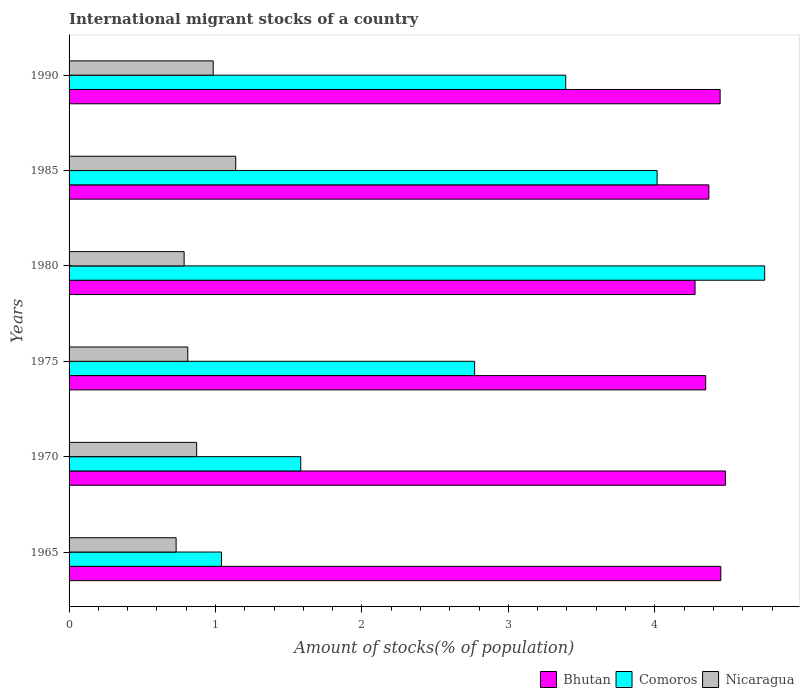How many groups of bars are there?
Provide a succinct answer. 6. Are the number of bars per tick equal to the number of legend labels?
Your answer should be very brief. Yes. Are the number of bars on each tick of the Y-axis equal?
Make the answer very short. Yes. How many bars are there on the 1st tick from the top?
Provide a succinct answer. 3. How many bars are there on the 1st tick from the bottom?
Ensure brevity in your answer.  3. What is the label of the 6th group of bars from the top?
Provide a succinct answer. 1965. In how many cases, is the number of bars for a given year not equal to the number of legend labels?
Your answer should be very brief. 0. What is the amount of stocks in in Nicaragua in 1990?
Ensure brevity in your answer.  0.98. Across all years, what is the maximum amount of stocks in in Comoros?
Your answer should be very brief. 4.75. Across all years, what is the minimum amount of stocks in in Comoros?
Provide a short and direct response. 1.04. In which year was the amount of stocks in in Comoros minimum?
Make the answer very short. 1965. What is the total amount of stocks in in Bhutan in the graph?
Your answer should be very brief. 26.37. What is the difference between the amount of stocks in in Comoros in 1965 and that in 1985?
Offer a terse response. -2.97. What is the difference between the amount of stocks in in Bhutan in 1990 and the amount of stocks in in Nicaragua in 1985?
Ensure brevity in your answer.  3.31. What is the average amount of stocks in in Bhutan per year?
Give a very brief answer. 4.39. In the year 1980, what is the difference between the amount of stocks in in Nicaragua and amount of stocks in in Comoros?
Provide a succinct answer. -3.96. In how many years, is the amount of stocks in in Comoros greater than 3.2 %?
Your response must be concise. 3. What is the ratio of the amount of stocks in in Nicaragua in 1965 to that in 1975?
Keep it short and to the point. 0.9. Is the difference between the amount of stocks in in Nicaragua in 1975 and 1990 greater than the difference between the amount of stocks in in Comoros in 1975 and 1990?
Keep it short and to the point. Yes. What is the difference between the highest and the second highest amount of stocks in in Comoros?
Provide a short and direct response. 0.73. What is the difference between the highest and the lowest amount of stocks in in Nicaragua?
Your response must be concise. 0.41. In how many years, is the amount of stocks in in Bhutan greater than the average amount of stocks in in Bhutan taken over all years?
Your answer should be very brief. 3. Is the sum of the amount of stocks in in Bhutan in 1965 and 1990 greater than the maximum amount of stocks in in Nicaragua across all years?
Offer a terse response. Yes. What does the 2nd bar from the top in 1975 represents?
Make the answer very short. Comoros. What does the 2nd bar from the bottom in 1990 represents?
Provide a succinct answer. Comoros. How many years are there in the graph?
Your response must be concise. 6. Are the values on the major ticks of X-axis written in scientific E-notation?
Give a very brief answer. No. Where does the legend appear in the graph?
Provide a short and direct response. Bottom right. How many legend labels are there?
Offer a terse response. 3. How are the legend labels stacked?
Provide a short and direct response. Horizontal. What is the title of the graph?
Give a very brief answer. International migrant stocks of a country. Does "Tanzania" appear as one of the legend labels in the graph?
Give a very brief answer. No. What is the label or title of the X-axis?
Give a very brief answer. Amount of stocks(% of population). What is the Amount of stocks(% of population) of Bhutan in 1965?
Make the answer very short. 4.45. What is the Amount of stocks(% of population) of Comoros in 1965?
Offer a very short reply. 1.04. What is the Amount of stocks(% of population) of Nicaragua in 1965?
Give a very brief answer. 0.73. What is the Amount of stocks(% of population) in Bhutan in 1970?
Offer a terse response. 4.48. What is the Amount of stocks(% of population) in Comoros in 1970?
Give a very brief answer. 1.58. What is the Amount of stocks(% of population) in Nicaragua in 1970?
Your response must be concise. 0.87. What is the Amount of stocks(% of population) of Bhutan in 1975?
Offer a terse response. 4.35. What is the Amount of stocks(% of population) in Comoros in 1975?
Your answer should be very brief. 2.77. What is the Amount of stocks(% of population) in Nicaragua in 1975?
Your response must be concise. 0.81. What is the Amount of stocks(% of population) in Bhutan in 1980?
Your answer should be very brief. 4.27. What is the Amount of stocks(% of population) in Comoros in 1980?
Give a very brief answer. 4.75. What is the Amount of stocks(% of population) in Nicaragua in 1980?
Your answer should be compact. 0.79. What is the Amount of stocks(% of population) of Bhutan in 1985?
Offer a terse response. 4.37. What is the Amount of stocks(% of population) of Comoros in 1985?
Make the answer very short. 4.02. What is the Amount of stocks(% of population) in Nicaragua in 1985?
Provide a succinct answer. 1.14. What is the Amount of stocks(% of population) in Bhutan in 1990?
Offer a terse response. 4.45. What is the Amount of stocks(% of population) of Comoros in 1990?
Make the answer very short. 3.39. What is the Amount of stocks(% of population) of Nicaragua in 1990?
Offer a terse response. 0.98. Across all years, what is the maximum Amount of stocks(% of population) of Bhutan?
Offer a very short reply. 4.48. Across all years, what is the maximum Amount of stocks(% of population) of Comoros?
Offer a very short reply. 4.75. Across all years, what is the maximum Amount of stocks(% of population) in Nicaragua?
Provide a succinct answer. 1.14. Across all years, what is the minimum Amount of stocks(% of population) of Bhutan?
Your answer should be very brief. 4.27. Across all years, what is the minimum Amount of stocks(% of population) of Comoros?
Ensure brevity in your answer.  1.04. Across all years, what is the minimum Amount of stocks(% of population) in Nicaragua?
Your answer should be compact. 0.73. What is the total Amount of stocks(% of population) of Bhutan in the graph?
Your answer should be compact. 26.37. What is the total Amount of stocks(% of population) in Comoros in the graph?
Keep it short and to the point. 17.55. What is the total Amount of stocks(% of population) of Nicaragua in the graph?
Provide a succinct answer. 5.32. What is the difference between the Amount of stocks(% of population) in Bhutan in 1965 and that in 1970?
Your response must be concise. -0.03. What is the difference between the Amount of stocks(% of population) of Comoros in 1965 and that in 1970?
Ensure brevity in your answer.  -0.54. What is the difference between the Amount of stocks(% of population) in Nicaragua in 1965 and that in 1970?
Your answer should be compact. -0.14. What is the difference between the Amount of stocks(% of population) of Bhutan in 1965 and that in 1975?
Give a very brief answer. 0.1. What is the difference between the Amount of stocks(% of population) in Comoros in 1965 and that in 1975?
Ensure brevity in your answer.  -1.73. What is the difference between the Amount of stocks(% of population) of Nicaragua in 1965 and that in 1975?
Your response must be concise. -0.08. What is the difference between the Amount of stocks(% of population) in Bhutan in 1965 and that in 1980?
Your response must be concise. 0.18. What is the difference between the Amount of stocks(% of population) in Comoros in 1965 and that in 1980?
Offer a very short reply. -3.71. What is the difference between the Amount of stocks(% of population) in Nicaragua in 1965 and that in 1980?
Offer a very short reply. -0.05. What is the difference between the Amount of stocks(% of population) in Bhutan in 1965 and that in 1985?
Offer a terse response. 0.08. What is the difference between the Amount of stocks(% of population) in Comoros in 1965 and that in 1985?
Your response must be concise. -2.97. What is the difference between the Amount of stocks(% of population) of Nicaragua in 1965 and that in 1985?
Your answer should be compact. -0.41. What is the difference between the Amount of stocks(% of population) in Bhutan in 1965 and that in 1990?
Your answer should be very brief. 0. What is the difference between the Amount of stocks(% of population) of Comoros in 1965 and that in 1990?
Your answer should be compact. -2.35. What is the difference between the Amount of stocks(% of population) of Nicaragua in 1965 and that in 1990?
Ensure brevity in your answer.  -0.25. What is the difference between the Amount of stocks(% of population) of Bhutan in 1970 and that in 1975?
Make the answer very short. 0.13. What is the difference between the Amount of stocks(% of population) in Comoros in 1970 and that in 1975?
Ensure brevity in your answer.  -1.19. What is the difference between the Amount of stocks(% of population) of Nicaragua in 1970 and that in 1975?
Keep it short and to the point. 0.06. What is the difference between the Amount of stocks(% of population) of Bhutan in 1970 and that in 1980?
Your answer should be very brief. 0.21. What is the difference between the Amount of stocks(% of population) of Comoros in 1970 and that in 1980?
Make the answer very short. -3.17. What is the difference between the Amount of stocks(% of population) of Nicaragua in 1970 and that in 1980?
Give a very brief answer. 0.09. What is the difference between the Amount of stocks(% of population) in Bhutan in 1970 and that in 1985?
Give a very brief answer. 0.11. What is the difference between the Amount of stocks(% of population) of Comoros in 1970 and that in 1985?
Keep it short and to the point. -2.43. What is the difference between the Amount of stocks(% of population) in Nicaragua in 1970 and that in 1985?
Provide a succinct answer. -0.27. What is the difference between the Amount of stocks(% of population) of Bhutan in 1970 and that in 1990?
Ensure brevity in your answer.  0.04. What is the difference between the Amount of stocks(% of population) in Comoros in 1970 and that in 1990?
Your response must be concise. -1.81. What is the difference between the Amount of stocks(% of population) of Nicaragua in 1970 and that in 1990?
Your response must be concise. -0.11. What is the difference between the Amount of stocks(% of population) in Bhutan in 1975 and that in 1980?
Make the answer very short. 0.07. What is the difference between the Amount of stocks(% of population) in Comoros in 1975 and that in 1980?
Your response must be concise. -1.98. What is the difference between the Amount of stocks(% of population) in Nicaragua in 1975 and that in 1980?
Give a very brief answer. 0.03. What is the difference between the Amount of stocks(% of population) in Bhutan in 1975 and that in 1985?
Your response must be concise. -0.02. What is the difference between the Amount of stocks(% of population) in Comoros in 1975 and that in 1985?
Keep it short and to the point. -1.25. What is the difference between the Amount of stocks(% of population) in Nicaragua in 1975 and that in 1985?
Provide a succinct answer. -0.33. What is the difference between the Amount of stocks(% of population) of Bhutan in 1975 and that in 1990?
Provide a short and direct response. -0.1. What is the difference between the Amount of stocks(% of population) of Comoros in 1975 and that in 1990?
Keep it short and to the point. -0.62. What is the difference between the Amount of stocks(% of population) of Nicaragua in 1975 and that in 1990?
Keep it short and to the point. -0.17. What is the difference between the Amount of stocks(% of population) of Bhutan in 1980 and that in 1985?
Your answer should be very brief. -0.09. What is the difference between the Amount of stocks(% of population) in Comoros in 1980 and that in 1985?
Offer a terse response. 0.73. What is the difference between the Amount of stocks(% of population) in Nicaragua in 1980 and that in 1985?
Offer a very short reply. -0.35. What is the difference between the Amount of stocks(% of population) of Bhutan in 1980 and that in 1990?
Provide a succinct answer. -0.17. What is the difference between the Amount of stocks(% of population) in Comoros in 1980 and that in 1990?
Provide a succinct answer. 1.36. What is the difference between the Amount of stocks(% of population) in Nicaragua in 1980 and that in 1990?
Give a very brief answer. -0.2. What is the difference between the Amount of stocks(% of population) in Bhutan in 1985 and that in 1990?
Keep it short and to the point. -0.08. What is the difference between the Amount of stocks(% of population) in Comoros in 1985 and that in 1990?
Offer a terse response. 0.62. What is the difference between the Amount of stocks(% of population) in Nicaragua in 1985 and that in 1990?
Your answer should be compact. 0.15. What is the difference between the Amount of stocks(% of population) in Bhutan in 1965 and the Amount of stocks(% of population) in Comoros in 1970?
Make the answer very short. 2.87. What is the difference between the Amount of stocks(% of population) in Bhutan in 1965 and the Amount of stocks(% of population) in Nicaragua in 1970?
Your response must be concise. 3.58. What is the difference between the Amount of stocks(% of population) in Comoros in 1965 and the Amount of stocks(% of population) in Nicaragua in 1970?
Offer a very short reply. 0.17. What is the difference between the Amount of stocks(% of population) in Bhutan in 1965 and the Amount of stocks(% of population) in Comoros in 1975?
Your response must be concise. 1.68. What is the difference between the Amount of stocks(% of population) in Bhutan in 1965 and the Amount of stocks(% of population) in Nicaragua in 1975?
Provide a short and direct response. 3.64. What is the difference between the Amount of stocks(% of population) of Comoros in 1965 and the Amount of stocks(% of population) of Nicaragua in 1975?
Your response must be concise. 0.23. What is the difference between the Amount of stocks(% of population) in Bhutan in 1965 and the Amount of stocks(% of population) in Comoros in 1980?
Provide a short and direct response. -0.3. What is the difference between the Amount of stocks(% of population) of Bhutan in 1965 and the Amount of stocks(% of population) of Nicaragua in 1980?
Your answer should be very brief. 3.66. What is the difference between the Amount of stocks(% of population) in Comoros in 1965 and the Amount of stocks(% of population) in Nicaragua in 1980?
Your answer should be compact. 0.26. What is the difference between the Amount of stocks(% of population) in Bhutan in 1965 and the Amount of stocks(% of population) in Comoros in 1985?
Your response must be concise. 0.44. What is the difference between the Amount of stocks(% of population) in Bhutan in 1965 and the Amount of stocks(% of population) in Nicaragua in 1985?
Offer a very short reply. 3.31. What is the difference between the Amount of stocks(% of population) in Comoros in 1965 and the Amount of stocks(% of population) in Nicaragua in 1985?
Make the answer very short. -0.1. What is the difference between the Amount of stocks(% of population) of Bhutan in 1965 and the Amount of stocks(% of population) of Comoros in 1990?
Make the answer very short. 1.06. What is the difference between the Amount of stocks(% of population) in Bhutan in 1965 and the Amount of stocks(% of population) in Nicaragua in 1990?
Provide a succinct answer. 3.47. What is the difference between the Amount of stocks(% of population) of Comoros in 1965 and the Amount of stocks(% of population) of Nicaragua in 1990?
Ensure brevity in your answer.  0.06. What is the difference between the Amount of stocks(% of population) of Bhutan in 1970 and the Amount of stocks(% of population) of Comoros in 1975?
Your answer should be compact. 1.71. What is the difference between the Amount of stocks(% of population) in Bhutan in 1970 and the Amount of stocks(% of population) in Nicaragua in 1975?
Your answer should be very brief. 3.67. What is the difference between the Amount of stocks(% of population) of Comoros in 1970 and the Amount of stocks(% of population) of Nicaragua in 1975?
Your response must be concise. 0.77. What is the difference between the Amount of stocks(% of population) of Bhutan in 1970 and the Amount of stocks(% of population) of Comoros in 1980?
Provide a succinct answer. -0.27. What is the difference between the Amount of stocks(% of population) in Bhutan in 1970 and the Amount of stocks(% of population) in Nicaragua in 1980?
Make the answer very short. 3.7. What is the difference between the Amount of stocks(% of population) in Comoros in 1970 and the Amount of stocks(% of population) in Nicaragua in 1980?
Your response must be concise. 0.8. What is the difference between the Amount of stocks(% of population) in Bhutan in 1970 and the Amount of stocks(% of population) in Comoros in 1985?
Your answer should be compact. 0.47. What is the difference between the Amount of stocks(% of population) of Bhutan in 1970 and the Amount of stocks(% of population) of Nicaragua in 1985?
Offer a terse response. 3.34. What is the difference between the Amount of stocks(% of population) of Comoros in 1970 and the Amount of stocks(% of population) of Nicaragua in 1985?
Give a very brief answer. 0.44. What is the difference between the Amount of stocks(% of population) in Bhutan in 1970 and the Amount of stocks(% of population) in Comoros in 1990?
Your response must be concise. 1.09. What is the difference between the Amount of stocks(% of population) in Bhutan in 1970 and the Amount of stocks(% of population) in Nicaragua in 1990?
Your response must be concise. 3.5. What is the difference between the Amount of stocks(% of population) in Comoros in 1970 and the Amount of stocks(% of population) in Nicaragua in 1990?
Keep it short and to the point. 0.6. What is the difference between the Amount of stocks(% of population) in Bhutan in 1975 and the Amount of stocks(% of population) in Comoros in 1980?
Your answer should be very brief. -0.4. What is the difference between the Amount of stocks(% of population) in Bhutan in 1975 and the Amount of stocks(% of population) in Nicaragua in 1980?
Offer a very short reply. 3.56. What is the difference between the Amount of stocks(% of population) of Comoros in 1975 and the Amount of stocks(% of population) of Nicaragua in 1980?
Make the answer very short. 1.98. What is the difference between the Amount of stocks(% of population) in Bhutan in 1975 and the Amount of stocks(% of population) in Comoros in 1985?
Ensure brevity in your answer.  0.33. What is the difference between the Amount of stocks(% of population) in Bhutan in 1975 and the Amount of stocks(% of population) in Nicaragua in 1985?
Provide a succinct answer. 3.21. What is the difference between the Amount of stocks(% of population) of Comoros in 1975 and the Amount of stocks(% of population) of Nicaragua in 1985?
Ensure brevity in your answer.  1.63. What is the difference between the Amount of stocks(% of population) of Bhutan in 1975 and the Amount of stocks(% of population) of Comoros in 1990?
Keep it short and to the point. 0.96. What is the difference between the Amount of stocks(% of population) in Bhutan in 1975 and the Amount of stocks(% of population) in Nicaragua in 1990?
Give a very brief answer. 3.36. What is the difference between the Amount of stocks(% of population) of Comoros in 1975 and the Amount of stocks(% of population) of Nicaragua in 1990?
Ensure brevity in your answer.  1.79. What is the difference between the Amount of stocks(% of population) in Bhutan in 1980 and the Amount of stocks(% of population) in Comoros in 1985?
Provide a succinct answer. 0.26. What is the difference between the Amount of stocks(% of population) of Bhutan in 1980 and the Amount of stocks(% of population) of Nicaragua in 1985?
Keep it short and to the point. 3.14. What is the difference between the Amount of stocks(% of population) in Comoros in 1980 and the Amount of stocks(% of population) in Nicaragua in 1985?
Your answer should be very brief. 3.61. What is the difference between the Amount of stocks(% of population) in Bhutan in 1980 and the Amount of stocks(% of population) in Comoros in 1990?
Your response must be concise. 0.88. What is the difference between the Amount of stocks(% of population) in Bhutan in 1980 and the Amount of stocks(% of population) in Nicaragua in 1990?
Give a very brief answer. 3.29. What is the difference between the Amount of stocks(% of population) of Comoros in 1980 and the Amount of stocks(% of population) of Nicaragua in 1990?
Give a very brief answer. 3.77. What is the difference between the Amount of stocks(% of population) in Bhutan in 1985 and the Amount of stocks(% of population) in Comoros in 1990?
Make the answer very short. 0.98. What is the difference between the Amount of stocks(% of population) of Bhutan in 1985 and the Amount of stocks(% of population) of Nicaragua in 1990?
Keep it short and to the point. 3.38. What is the difference between the Amount of stocks(% of population) of Comoros in 1985 and the Amount of stocks(% of population) of Nicaragua in 1990?
Keep it short and to the point. 3.03. What is the average Amount of stocks(% of population) of Bhutan per year?
Offer a terse response. 4.39. What is the average Amount of stocks(% of population) in Comoros per year?
Provide a succinct answer. 2.92. What is the average Amount of stocks(% of population) in Nicaragua per year?
Provide a succinct answer. 0.89. In the year 1965, what is the difference between the Amount of stocks(% of population) of Bhutan and Amount of stocks(% of population) of Comoros?
Provide a succinct answer. 3.41. In the year 1965, what is the difference between the Amount of stocks(% of population) of Bhutan and Amount of stocks(% of population) of Nicaragua?
Make the answer very short. 3.72. In the year 1965, what is the difference between the Amount of stocks(% of population) in Comoros and Amount of stocks(% of population) in Nicaragua?
Your answer should be compact. 0.31. In the year 1970, what is the difference between the Amount of stocks(% of population) of Bhutan and Amount of stocks(% of population) of Nicaragua?
Offer a very short reply. 3.61. In the year 1970, what is the difference between the Amount of stocks(% of population) of Comoros and Amount of stocks(% of population) of Nicaragua?
Make the answer very short. 0.71. In the year 1975, what is the difference between the Amount of stocks(% of population) of Bhutan and Amount of stocks(% of population) of Comoros?
Offer a terse response. 1.58. In the year 1975, what is the difference between the Amount of stocks(% of population) of Bhutan and Amount of stocks(% of population) of Nicaragua?
Keep it short and to the point. 3.54. In the year 1975, what is the difference between the Amount of stocks(% of population) in Comoros and Amount of stocks(% of population) in Nicaragua?
Make the answer very short. 1.96. In the year 1980, what is the difference between the Amount of stocks(% of population) of Bhutan and Amount of stocks(% of population) of Comoros?
Offer a terse response. -0.48. In the year 1980, what is the difference between the Amount of stocks(% of population) in Bhutan and Amount of stocks(% of population) in Nicaragua?
Your answer should be very brief. 3.49. In the year 1980, what is the difference between the Amount of stocks(% of population) of Comoros and Amount of stocks(% of population) of Nicaragua?
Keep it short and to the point. 3.96. In the year 1985, what is the difference between the Amount of stocks(% of population) in Bhutan and Amount of stocks(% of population) in Comoros?
Provide a succinct answer. 0.35. In the year 1985, what is the difference between the Amount of stocks(% of population) of Bhutan and Amount of stocks(% of population) of Nicaragua?
Keep it short and to the point. 3.23. In the year 1985, what is the difference between the Amount of stocks(% of population) in Comoros and Amount of stocks(% of population) in Nicaragua?
Your answer should be compact. 2.88. In the year 1990, what is the difference between the Amount of stocks(% of population) in Bhutan and Amount of stocks(% of population) in Comoros?
Keep it short and to the point. 1.05. In the year 1990, what is the difference between the Amount of stocks(% of population) in Bhutan and Amount of stocks(% of population) in Nicaragua?
Your answer should be compact. 3.46. In the year 1990, what is the difference between the Amount of stocks(% of population) in Comoros and Amount of stocks(% of population) in Nicaragua?
Your answer should be very brief. 2.41. What is the ratio of the Amount of stocks(% of population) in Bhutan in 1965 to that in 1970?
Keep it short and to the point. 0.99. What is the ratio of the Amount of stocks(% of population) of Comoros in 1965 to that in 1970?
Your answer should be very brief. 0.66. What is the ratio of the Amount of stocks(% of population) of Nicaragua in 1965 to that in 1970?
Ensure brevity in your answer.  0.84. What is the ratio of the Amount of stocks(% of population) in Bhutan in 1965 to that in 1975?
Keep it short and to the point. 1.02. What is the ratio of the Amount of stocks(% of population) of Comoros in 1965 to that in 1975?
Provide a short and direct response. 0.38. What is the ratio of the Amount of stocks(% of population) in Nicaragua in 1965 to that in 1975?
Offer a terse response. 0.9. What is the ratio of the Amount of stocks(% of population) of Bhutan in 1965 to that in 1980?
Provide a succinct answer. 1.04. What is the ratio of the Amount of stocks(% of population) of Comoros in 1965 to that in 1980?
Your answer should be compact. 0.22. What is the ratio of the Amount of stocks(% of population) in Nicaragua in 1965 to that in 1980?
Make the answer very short. 0.93. What is the ratio of the Amount of stocks(% of population) in Bhutan in 1965 to that in 1985?
Provide a short and direct response. 1.02. What is the ratio of the Amount of stocks(% of population) of Comoros in 1965 to that in 1985?
Your response must be concise. 0.26. What is the ratio of the Amount of stocks(% of population) of Nicaragua in 1965 to that in 1985?
Ensure brevity in your answer.  0.64. What is the ratio of the Amount of stocks(% of population) in Comoros in 1965 to that in 1990?
Ensure brevity in your answer.  0.31. What is the ratio of the Amount of stocks(% of population) in Nicaragua in 1965 to that in 1990?
Offer a very short reply. 0.74. What is the ratio of the Amount of stocks(% of population) in Bhutan in 1970 to that in 1975?
Provide a succinct answer. 1.03. What is the ratio of the Amount of stocks(% of population) of Comoros in 1970 to that in 1975?
Keep it short and to the point. 0.57. What is the ratio of the Amount of stocks(% of population) in Nicaragua in 1970 to that in 1975?
Keep it short and to the point. 1.07. What is the ratio of the Amount of stocks(% of population) in Bhutan in 1970 to that in 1980?
Ensure brevity in your answer.  1.05. What is the ratio of the Amount of stocks(% of population) of Comoros in 1970 to that in 1980?
Your answer should be compact. 0.33. What is the ratio of the Amount of stocks(% of population) in Nicaragua in 1970 to that in 1980?
Make the answer very short. 1.11. What is the ratio of the Amount of stocks(% of population) in Bhutan in 1970 to that in 1985?
Offer a terse response. 1.03. What is the ratio of the Amount of stocks(% of population) in Comoros in 1970 to that in 1985?
Give a very brief answer. 0.39. What is the ratio of the Amount of stocks(% of population) in Nicaragua in 1970 to that in 1985?
Offer a terse response. 0.77. What is the ratio of the Amount of stocks(% of population) of Bhutan in 1970 to that in 1990?
Your response must be concise. 1.01. What is the ratio of the Amount of stocks(% of population) in Comoros in 1970 to that in 1990?
Give a very brief answer. 0.47. What is the ratio of the Amount of stocks(% of population) of Nicaragua in 1970 to that in 1990?
Ensure brevity in your answer.  0.89. What is the ratio of the Amount of stocks(% of population) of Comoros in 1975 to that in 1980?
Your response must be concise. 0.58. What is the ratio of the Amount of stocks(% of population) of Nicaragua in 1975 to that in 1980?
Make the answer very short. 1.03. What is the ratio of the Amount of stocks(% of population) in Comoros in 1975 to that in 1985?
Ensure brevity in your answer.  0.69. What is the ratio of the Amount of stocks(% of population) in Nicaragua in 1975 to that in 1985?
Offer a terse response. 0.71. What is the ratio of the Amount of stocks(% of population) of Bhutan in 1975 to that in 1990?
Provide a succinct answer. 0.98. What is the ratio of the Amount of stocks(% of population) in Comoros in 1975 to that in 1990?
Provide a short and direct response. 0.82. What is the ratio of the Amount of stocks(% of population) of Nicaragua in 1975 to that in 1990?
Your response must be concise. 0.82. What is the ratio of the Amount of stocks(% of population) in Bhutan in 1980 to that in 1985?
Ensure brevity in your answer.  0.98. What is the ratio of the Amount of stocks(% of population) in Comoros in 1980 to that in 1985?
Provide a short and direct response. 1.18. What is the ratio of the Amount of stocks(% of population) of Nicaragua in 1980 to that in 1985?
Your answer should be compact. 0.69. What is the ratio of the Amount of stocks(% of population) of Bhutan in 1980 to that in 1990?
Ensure brevity in your answer.  0.96. What is the ratio of the Amount of stocks(% of population) of Comoros in 1980 to that in 1990?
Ensure brevity in your answer.  1.4. What is the ratio of the Amount of stocks(% of population) of Nicaragua in 1980 to that in 1990?
Provide a succinct answer. 0.8. What is the ratio of the Amount of stocks(% of population) in Bhutan in 1985 to that in 1990?
Offer a terse response. 0.98. What is the ratio of the Amount of stocks(% of population) of Comoros in 1985 to that in 1990?
Your answer should be compact. 1.18. What is the ratio of the Amount of stocks(% of population) in Nicaragua in 1985 to that in 1990?
Make the answer very short. 1.16. What is the difference between the highest and the second highest Amount of stocks(% of population) in Bhutan?
Your answer should be compact. 0.03. What is the difference between the highest and the second highest Amount of stocks(% of population) in Comoros?
Provide a succinct answer. 0.73. What is the difference between the highest and the second highest Amount of stocks(% of population) of Nicaragua?
Provide a short and direct response. 0.15. What is the difference between the highest and the lowest Amount of stocks(% of population) of Bhutan?
Provide a short and direct response. 0.21. What is the difference between the highest and the lowest Amount of stocks(% of population) in Comoros?
Your answer should be very brief. 3.71. What is the difference between the highest and the lowest Amount of stocks(% of population) of Nicaragua?
Provide a short and direct response. 0.41. 